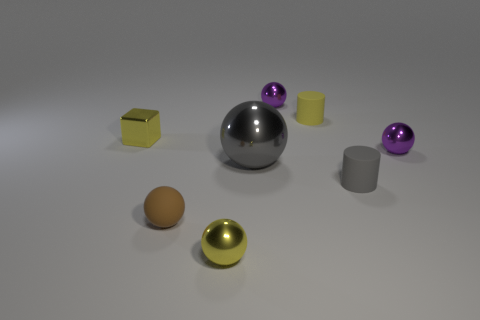Is there anything else that has the same size as the gray metallic thing?
Your response must be concise. No. What number of other objects are the same size as the yellow cylinder?
Provide a succinct answer. 6. Are there any cylinders that have the same color as the large shiny sphere?
Your answer should be very brief. Yes. How many yellow metal things are the same size as the yellow cube?
Your answer should be very brief. 1. Is the number of large gray metallic spheres in front of the brown matte thing the same as the number of small purple shiny blocks?
Make the answer very short. Yes. What number of small things are both in front of the large metal object and to the right of the yellow cylinder?
Offer a terse response. 1. The yellow object that is the same material as the small cube is what size?
Your response must be concise. Small. How many small purple things have the same shape as the brown object?
Keep it short and to the point. 2. Is the number of cubes that are behind the tiny yellow sphere greater than the number of big yellow shiny objects?
Make the answer very short. Yes. What shape is the tiny yellow object that is both to the right of the brown ball and behind the big shiny sphere?
Provide a short and direct response. Cylinder. 